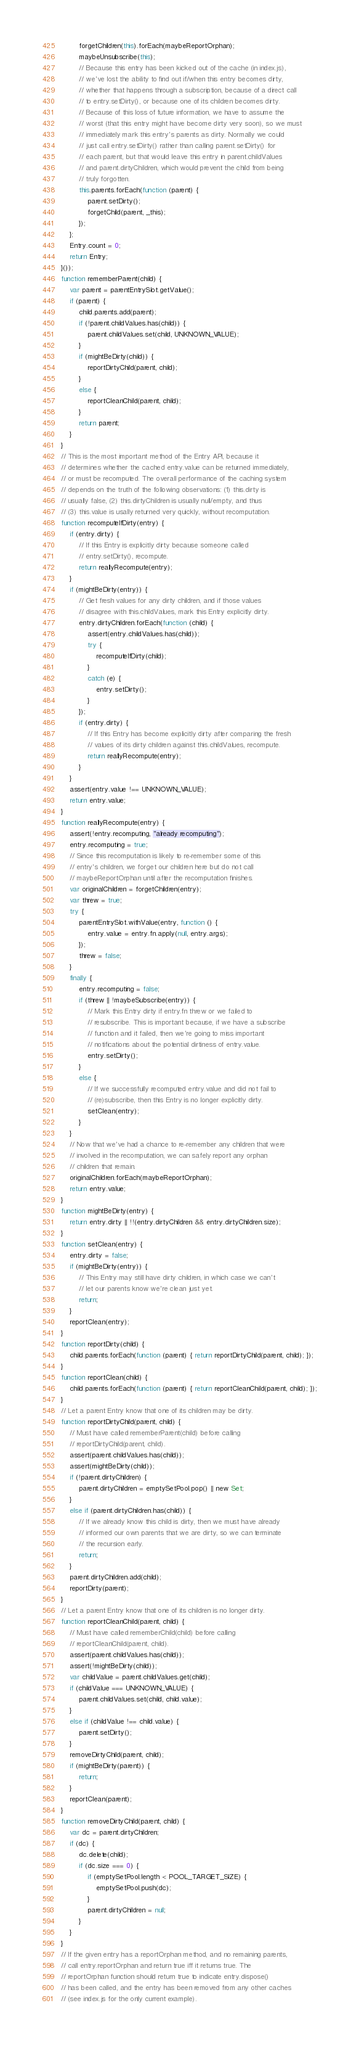Convert code to text. <code><loc_0><loc_0><loc_500><loc_500><_JavaScript_>        forgetChildren(this).forEach(maybeReportOrphan);
        maybeUnsubscribe(this);
        // Because this entry has been kicked out of the cache (in index.js),
        // we've lost the ability to find out if/when this entry becomes dirty,
        // whether that happens through a subscription, because of a direct call
        // to entry.setDirty(), or because one of its children becomes dirty.
        // Because of this loss of future information, we have to assume the
        // worst (that this entry might have become dirty very soon), so we must
        // immediately mark this entry's parents as dirty. Normally we could
        // just call entry.setDirty() rather than calling parent.setDirty() for
        // each parent, but that would leave this entry in parent.childValues
        // and parent.dirtyChildren, which would prevent the child from being
        // truly forgotten.
        this.parents.forEach(function (parent) {
            parent.setDirty();
            forgetChild(parent, _this);
        });
    };
    Entry.count = 0;
    return Entry;
}());
function rememberParent(child) {
    var parent = parentEntrySlot.getValue();
    if (parent) {
        child.parents.add(parent);
        if (!parent.childValues.has(child)) {
            parent.childValues.set(child, UNKNOWN_VALUE);
        }
        if (mightBeDirty(child)) {
            reportDirtyChild(parent, child);
        }
        else {
            reportCleanChild(parent, child);
        }
        return parent;
    }
}
// This is the most important method of the Entry API, because it
// determines whether the cached entry.value can be returned immediately,
// or must be recomputed. The overall performance of the caching system
// depends on the truth of the following observations: (1) this.dirty is
// usually false, (2) this.dirtyChildren is usually null/empty, and thus
// (3) this.value is usally returned very quickly, without recomputation.
function recomputeIfDirty(entry) {
    if (entry.dirty) {
        // If this Entry is explicitly dirty because someone called
        // entry.setDirty(), recompute.
        return reallyRecompute(entry);
    }
    if (mightBeDirty(entry)) {
        // Get fresh values for any dirty children, and if those values
        // disagree with this.childValues, mark this Entry explicitly dirty.
        entry.dirtyChildren.forEach(function (child) {
            assert(entry.childValues.has(child));
            try {
                recomputeIfDirty(child);
            }
            catch (e) {
                entry.setDirty();
            }
        });
        if (entry.dirty) {
            // If this Entry has become explicitly dirty after comparing the fresh
            // values of its dirty children against this.childValues, recompute.
            return reallyRecompute(entry);
        }
    }
    assert(entry.value !== UNKNOWN_VALUE);
    return entry.value;
}
function reallyRecompute(entry) {
    assert(!entry.recomputing, "already recomputing");
    entry.recomputing = true;
    // Since this recomputation is likely to re-remember some of this
    // entry's children, we forget our children here but do not call
    // maybeReportOrphan until after the recomputation finishes.
    var originalChildren = forgetChildren(entry);
    var threw = true;
    try {
        parentEntrySlot.withValue(entry, function () {
            entry.value = entry.fn.apply(null, entry.args);
        });
        threw = false;
    }
    finally {
        entry.recomputing = false;
        if (threw || !maybeSubscribe(entry)) {
            // Mark this Entry dirty if entry.fn threw or we failed to
            // resubscribe. This is important because, if we have a subscribe
            // function and it failed, then we're going to miss important
            // notifications about the potential dirtiness of entry.value.
            entry.setDirty();
        }
        else {
            // If we successfully recomputed entry.value and did not fail to
            // (re)subscribe, then this Entry is no longer explicitly dirty.
            setClean(entry);
        }
    }
    // Now that we've had a chance to re-remember any children that were
    // involved in the recomputation, we can safely report any orphan
    // children that remain.
    originalChildren.forEach(maybeReportOrphan);
    return entry.value;
}
function mightBeDirty(entry) {
    return entry.dirty || !!(entry.dirtyChildren && entry.dirtyChildren.size);
}
function setClean(entry) {
    entry.dirty = false;
    if (mightBeDirty(entry)) {
        // This Entry may still have dirty children, in which case we can't
        // let our parents know we're clean just yet.
        return;
    }
    reportClean(entry);
}
function reportDirty(child) {
    child.parents.forEach(function (parent) { return reportDirtyChild(parent, child); });
}
function reportClean(child) {
    child.parents.forEach(function (parent) { return reportCleanChild(parent, child); });
}
// Let a parent Entry know that one of its children may be dirty.
function reportDirtyChild(parent, child) {
    // Must have called rememberParent(child) before calling
    // reportDirtyChild(parent, child).
    assert(parent.childValues.has(child));
    assert(mightBeDirty(child));
    if (!parent.dirtyChildren) {
        parent.dirtyChildren = emptySetPool.pop() || new Set;
    }
    else if (parent.dirtyChildren.has(child)) {
        // If we already know this child is dirty, then we must have already
        // informed our own parents that we are dirty, so we can terminate
        // the recursion early.
        return;
    }
    parent.dirtyChildren.add(child);
    reportDirty(parent);
}
// Let a parent Entry know that one of its children is no longer dirty.
function reportCleanChild(parent, child) {
    // Must have called rememberChild(child) before calling
    // reportCleanChild(parent, child).
    assert(parent.childValues.has(child));
    assert(!mightBeDirty(child));
    var childValue = parent.childValues.get(child);
    if (childValue === UNKNOWN_VALUE) {
        parent.childValues.set(child, child.value);
    }
    else if (childValue !== child.value) {
        parent.setDirty();
    }
    removeDirtyChild(parent, child);
    if (mightBeDirty(parent)) {
        return;
    }
    reportClean(parent);
}
function removeDirtyChild(parent, child) {
    var dc = parent.dirtyChildren;
    if (dc) {
        dc.delete(child);
        if (dc.size === 0) {
            if (emptySetPool.length < POOL_TARGET_SIZE) {
                emptySetPool.push(dc);
            }
            parent.dirtyChildren = null;
        }
    }
}
// If the given entry has a reportOrphan method, and no remaining parents,
// call entry.reportOrphan and return true iff it returns true. The
// reportOrphan function should return true to indicate entry.dispose()
// has been called, and the entry has been removed from any other caches
// (see index.js for the only current example).</code> 